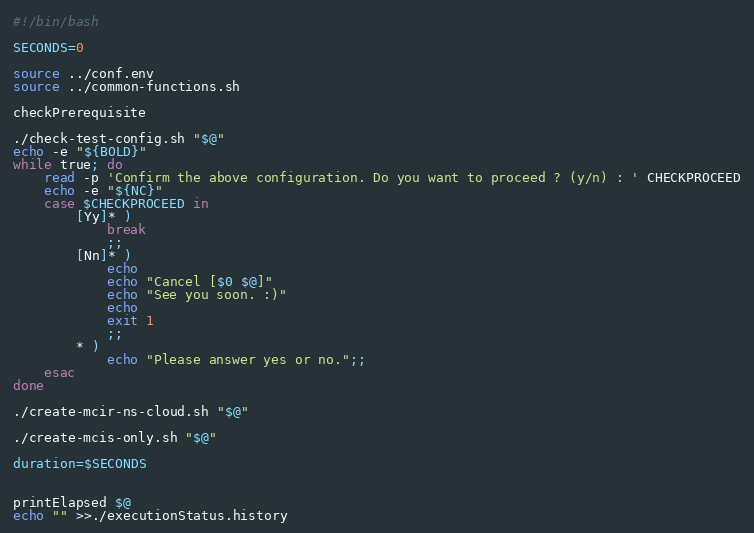<code> <loc_0><loc_0><loc_500><loc_500><_Bash_>#!/bin/bash

SECONDS=0

source ../conf.env
source ../common-functions.sh

checkPrerequisite

./check-test-config.sh "$@"
echo -e "${BOLD}"
while true; do
    read -p 'Confirm the above configuration. Do you want to proceed ? (y/n) : ' CHECKPROCEED
    echo -e "${NC}"
    case $CHECKPROCEED in
        [Yy]* ) 
            break
            ;;
        [Nn]* ) 
            echo
            echo "Cancel [$0 $@]"
            echo "See you soon. :)"
            echo
            exit 1
            ;;
        * ) 
            echo "Please answer yes or no.";;
    esac
done

./create-mcir-ns-cloud.sh "$@"

./create-mcis-only.sh "$@"

duration=$SECONDS


printElapsed $@
echo "" >>./executionStatus.history

</code> 